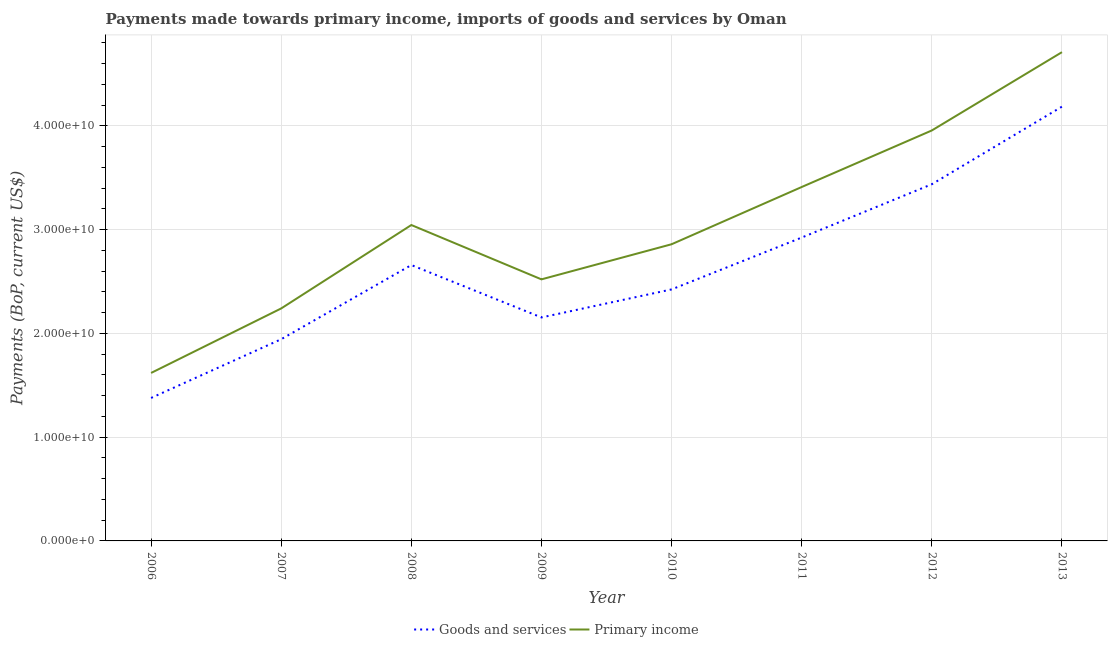What is the payments made towards primary income in 2013?
Make the answer very short. 4.71e+1. Across all years, what is the maximum payments made towards primary income?
Provide a succinct answer. 4.71e+1. Across all years, what is the minimum payments made towards primary income?
Provide a succinct answer. 1.62e+1. In which year was the payments made towards goods and services minimum?
Your answer should be compact. 2006. What is the total payments made towards primary income in the graph?
Make the answer very short. 2.44e+11. What is the difference between the payments made towards primary income in 2006 and that in 2012?
Offer a very short reply. -2.34e+1. What is the difference between the payments made towards goods and services in 2013 and the payments made towards primary income in 2008?
Your response must be concise. 1.14e+1. What is the average payments made towards goods and services per year?
Offer a very short reply. 2.64e+1. In the year 2007, what is the difference between the payments made towards goods and services and payments made towards primary income?
Your answer should be compact. -2.97e+09. What is the ratio of the payments made towards primary income in 2012 to that in 2013?
Keep it short and to the point. 0.84. Is the payments made towards goods and services in 2006 less than that in 2011?
Give a very brief answer. Yes. What is the difference between the highest and the second highest payments made towards primary income?
Provide a short and direct response. 7.54e+09. What is the difference between the highest and the lowest payments made towards goods and services?
Make the answer very short. 2.81e+1. Is the sum of the payments made towards primary income in 2010 and 2013 greater than the maximum payments made towards goods and services across all years?
Provide a succinct answer. Yes. Is the payments made towards primary income strictly greater than the payments made towards goods and services over the years?
Your answer should be compact. Yes. Is the payments made towards primary income strictly less than the payments made towards goods and services over the years?
Make the answer very short. No. What is the difference between two consecutive major ticks on the Y-axis?
Make the answer very short. 1.00e+1. Are the values on the major ticks of Y-axis written in scientific E-notation?
Provide a succinct answer. Yes. Does the graph contain any zero values?
Ensure brevity in your answer.  No. Does the graph contain grids?
Keep it short and to the point. Yes. Where does the legend appear in the graph?
Offer a terse response. Bottom center. What is the title of the graph?
Keep it short and to the point. Payments made towards primary income, imports of goods and services by Oman. What is the label or title of the Y-axis?
Your response must be concise. Payments (BoP, current US$). What is the Payments (BoP, current US$) in Goods and services in 2006?
Your response must be concise. 1.38e+1. What is the Payments (BoP, current US$) in Primary income in 2006?
Offer a very short reply. 1.62e+1. What is the Payments (BoP, current US$) in Goods and services in 2007?
Offer a terse response. 1.94e+1. What is the Payments (BoP, current US$) in Primary income in 2007?
Ensure brevity in your answer.  2.24e+1. What is the Payments (BoP, current US$) in Goods and services in 2008?
Give a very brief answer. 2.66e+1. What is the Payments (BoP, current US$) of Primary income in 2008?
Your answer should be compact. 3.04e+1. What is the Payments (BoP, current US$) in Goods and services in 2009?
Offer a very short reply. 2.15e+1. What is the Payments (BoP, current US$) in Primary income in 2009?
Offer a terse response. 2.52e+1. What is the Payments (BoP, current US$) of Goods and services in 2010?
Your answer should be very brief. 2.42e+1. What is the Payments (BoP, current US$) in Primary income in 2010?
Ensure brevity in your answer.  2.86e+1. What is the Payments (BoP, current US$) in Goods and services in 2011?
Your answer should be very brief. 2.92e+1. What is the Payments (BoP, current US$) of Primary income in 2011?
Ensure brevity in your answer.  3.41e+1. What is the Payments (BoP, current US$) in Goods and services in 2012?
Make the answer very short. 3.44e+1. What is the Payments (BoP, current US$) in Primary income in 2012?
Your answer should be compact. 3.96e+1. What is the Payments (BoP, current US$) of Goods and services in 2013?
Keep it short and to the point. 4.18e+1. What is the Payments (BoP, current US$) in Primary income in 2013?
Your response must be concise. 4.71e+1. Across all years, what is the maximum Payments (BoP, current US$) in Goods and services?
Offer a very short reply. 4.18e+1. Across all years, what is the maximum Payments (BoP, current US$) in Primary income?
Offer a terse response. 4.71e+1. Across all years, what is the minimum Payments (BoP, current US$) of Goods and services?
Give a very brief answer. 1.38e+1. Across all years, what is the minimum Payments (BoP, current US$) of Primary income?
Provide a succinct answer. 1.62e+1. What is the total Payments (BoP, current US$) in Goods and services in the graph?
Make the answer very short. 2.11e+11. What is the total Payments (BoP, current US$) in Primary income in the graph?
Offer a terse response. 2.44e+11. What is the difference between the Payments (BoP, current US$) in Goods and services in 2006 and that in 2007?
Give a very brief answer. -5.66e+09. What is the difference between the Payments (BoP, current US$) of Primary income in 2006 and that in 2007?
Keep it short and to the point. -6.22e+09. What is the difference between the Payments (BoP, current US$) in Goods and services in 2006 and that in 2008?
Provide a short and direct response. -1.28e+1. What is the difference between the Payments (BoP, current US$) of Primary income in 2006 and that in 2008?
Ensure brevity in your answer.  -1.43e+1. What is the difference between the Payments (BoP, current US$) in Goods and services in 2006 and that in 2009?
Your response must be concise. -7.76e+09. What is the difference between the Payments (BoP, current US$) in Primary income in 2006 and that in 2009?
Make the answer very short. -9.02e+09. What is the difference between the Payments (BoP, current US$) in Goods and services in 2006 and that in 2010?
Keep it short and to the point. -1.05e+1. What is the difference between the Payments (BoP, current US$) in Primary income in 2006 and that in 2010?
Keep it short and to the point. -1.24e+1. What is the difference between the Payments (BoP, current US$) in Goods and services in 2006 and that in 2011?
Give a very brief answer. -1.55e+1. What is the difference between the Payments (BoP, current US$) in Primary income in 2006 and that in 2011?
Keep it short and to the point. -1.79e+1. What is the difference between the Payments (BoP, current US$) in Goods and services in 2006 and that in 2012?
Provide a short and direct response. -2.06e+1. What is the difference between the Payments (BoP, current US$) in Primary income in 2006 and that in 2012?
Your response must be concise. -2.34e+1. What is the difference between the Payments (BoP, current US$) of Goods and services in 2006 and that in 2013?
Ensure brevity in your answer.  -2.81e+1. What is the difference between the Payments (BoP, current US$) of Primary income in 2006 and that in 2013?
Your response must be concise. -3.09e+1. What is the difference between the Payments (BoP, current US$) in Goods and services in 2007 and that in 2008?
Give a very brief answer. -7.15e+09. What is the difference between the Payments (BoP, current US$) of Primary income in 2007 and that in 2008?
Provide a short and direct response. -8.04e+09. What is the difference between the Payments (BoP, current US$) of Goods and services in 2007 and that in 2009?
Your answer should be very brief. -2.10e+09. What is the difference between the Payments (BoP, current US$) in Primary income in 2007 and that in 2009?
Provide a succinct answer. -2.80e+09. What is the difference between the Payments (BoP, current US$) of Goods and services in 2007 and that in 2010?
Your response must be concise. -4.80e+09. What is the difference between the Payments (BoP, current US$) in Primary income in 2007 and that in 2010?
Provide a succinct answer. -6.19e+09. What is the difference between the Payments (BoP, current US$) in Goods and services in 2007 and that in 2011?
Offer a very short reply. -9.80e+09. What is the difference between the Payments (BoP, current US$) in Primary income in 2007 and that in 2011?
Make the answer very short. -1.17e+1. What is the difference between the Payments (BoP, current US$) of Goods and services in 2007 and that in 2012?
Provide a succinct answer. -1.49e+1. What is the difference between the Payments (BoP, current US$) in Primary income in 2007 and that in 2012?
Provide a short and direct response. -1.72e+1. What is the difference between the Payments (BoP, current US$) of Goods and services in 2007 and that in 2013?
Your response must be concise. -2.24e+1. What is the difference between the Payments (BoP, current US$) in Primary income in 2007 and that in 2013?
Your response must be concise. -2.47e+1. What is the difference between the Payments (BoP, current US$) in Goods and services in 2008 and that in 2009?
Provide a short and direct response. 5.05e+09. What is the difference between the Payments (BoP, current US$) in Primary income in 2008 and that in 2009?
Your answer should be compact. 5.24e+09. What is the difference between the Payments (BoP, current US$) in Goods and services in 2008 and that in 2010?
Your response must be concise. 2.35e+09. What is the difference between the Payments (BoP, current US$) of Primary income in 2008 and that in 2010?
Provide a short and direct response. 1.85e+09. What is the difference between the Payments (BoP, current US$) of Goods and services in 2008 and that in 2011?
Provide a succinct answer. -2.65e+09. What is the difference between the Payments (BoP, current US$) in Primary income in 2008 and that in 2011?
Your response must be concise. -3.66e+09. What is the difference between the Payments (BoP, current US$) of Goods and services in 2008 and that in 2012?
Offer a terse response. -7.79e+09. What is the difference between the Payments (BoP, current US$) of Primary income in 2008 and that in 2012?
Offer a very short reply. -9.11e+09. What is the difference between the Payments (BoP, current US$) in Goods and services in 2008 and that in 2013?
Offer a terse response. -1.53e+1. What is the difference between the Payments (BoP, current US$) in Primary income in 2008 and that in 2013?
Provide a short and direct response. -1.67e+1. What is the difference between the Payments (BoP, current US$) of Goods and services in 2009 and that in 2010?
Keep it short and to the point. -2.70e+09. What is the difference between the Payments (BoP, current US$) in Primary income in 2009 and that in 2010?
Provide a short and direct response. -3.38e+09. What is the difference between the Payments (BoP, current US$) in Goods and services in 2009 and that in 2011?
Make the answer very short. -7.70e+09. What is the difference between the Payments (BoP, current US$) in Primary income in 2009 and that in 2011?
Provide a short and direct response. -8.90e+09. What is the difference between the Payments (BoP, current US$) of Goods and services in 2009 and that in 2012?
Provide a short and direct response. -1.28e+1. What is the difference between the Payments (BoP, current US$) of Primary income in 2009 and that in 2012?
Make the answer very short. -1.43e+1. What is the difference between the Payments (BoP, current US$) in Goods and services in 2009 and that in 2013?
Offer a terse response. -2.03e+1. What is the difference between the Payments (BoP, current US$) in Primary income in 2009 and that in 2013?
Ensure brevity in your answer.  -2.19e+1. What is the difference between the Payments (BoP, current US$) in Goods and services in 2010 and that in 2011?
Make the answer very short. -5.00e+09. What is the difference between the Payments (BoP, current US$) of Primary income in 2010 and that in 2011?
Your answer should be very brief. -5.52e+09. What is the difference between the Payments (BoP, current US$) of Goods and services in 2010 and that in 2012?
Your answer should be compact. -1.01e+1. What is the difference between the Payments (BoP, current US$) in Primary income in 2010 and that in 2012?
Your answer should be very brief. -1.10e+1. What is the difference between the Payments (BoP, current US$) in Goods and services in 2010 and that in 2013?
Give a very brief answer. -1.76e+1. What is the difference between the Payments (BoP, current US$) in Primary income in 2010 and that in 2013?
Your answer should be compact. -1.85e+1. What is the difference between the Payments (BoP, current US$) in Goods and services in 2011 and that in 2012?
Your response must be concise. -5.14e+09. What is the difference between the Payments (BoP, current US$) of Primary income in 2011 and that in 2012?
Make the answer very short. -5.45e+09. What is the difference between the Payments (BoP, current US$) of Goods and services in 2011 and that in 2013?
Ensure brevity in your answer.  -1.26e+1. What is the difference between the Payments (BoP, current US$) in Primary income in 2011 and that in 2013?
Give a very brief answer. -1.30e+1. What is the difference between the Payments (BoP, current US$) in Goods and services in 2012 and that in 2013?
Keep it short and to the point. -7.48e+09. What is the difference between the Payments (BoP, current US$) in Primary income in 2012 and that in 2013?
Ensure brevity in your answer.  -7.54e+09. What is the difference between the Payments (BoP, current US$) of Goods and services in 2006 and the Payments (BoP, current US$) of Primary income in 2007?
Your answer should be very brief. -8.63e+09. What is the difference between the Payments (BoP, current US$) in Goods and services in 2006 and the Payments (BoP, current US$) in Primary income in 2008?
Ensure brevity in your answer.  -1.67e+1. What is the difference between the Payments (BoP, current US$) of Goods and services in 2006 and the Payments (BoP, current US$) of Primary income in 2009?
Provide a succinct answer. -1.14e+1. What is the difference between the Payments (BoP, current US$) of Goods and services in 2006 and the Payments (BoP, current US$) of Primary income in 2010?
Your answer should be very brief. -1.48e+1. What is the difference between the Payments (BoP, current US$) in Goods and services in 2006 and the Payments (BoP, current US$) in Primary income in 2011?
Keep it short and to the point. -2.03e+1. What is the difference between the Payments (BoP, current US$) of Goods and services in 2006 and the Payments (BoP, current US$) of Primary income in 2012?
Provide a succinct answer. -2.58e+1. What is the difference between the Payments (BoP, current US$) in Goods and services in 2006 and the Payments (BoP, current US$) in Primary income in 2013?
Make the answer very short. -3.33e+1. What is the difference between the Payments (BoP, current US$) of Goods and services in 2007 and the Payments (BoP, current US$) of Primary income in 2008?
Give a very brief answer. -1.10e+1. What is the difference between the Payments (BoP, current US$) in Goods and services in 2007 and the Payments (BoP, current US$) in Primary income in 2009?
Keep it short and to the point. -5.77e+09. What is the difference between the Payments (BoP, current US$) in Goods and services in 2007 and the Payments (BoP, current US$) in Primary income in 2010?
Offer a terse response. -9.15e+09. What is the difference between the Payments (BoP, current US$) in Goods and services in 2007 and the Payments (BoP, current US$) in Primary income in 2011?
Your answer should be compact. -1.47e+1. What is the difference between the Payments (BoP, current US$) of Goods and services in 2007 and the Payments (BoP, current US$) of Primary income in 2012?
Give a very brief answer. -2.01e+1. What is the difference between the Payments (BoP, current US$) of Goods and services in 2007 and the Payments (BoP, current US$) of Primary income in 2013?
Give a very brief answer. -2.77e+1. What is the difference between the Payments (BoP, current US$) in Goods and services in 2008 and the Payments (BoP, current US$) in Primary income in 2009?
Your answer should be very brief. 1.38e+09. What is the difference between the Payments (BoP, current US$) in Goods and services in 2008 and the Payments (BoP, current US$) in Primary income in 2010?
Provide a short and direct response. -2.00e+09. What is the difference between the Payments (BoP, current US$) of Goods and services in 2008 and the Payments (BoP, current US$) of Primary income in 2011?
Make the answer very short. -7.52e+09. What is the difference between the Payments (BoP, current US$) in Goods and services in 2008 and the Payments (BoP, current US$) in Primary income in 2012?
Keep it short and to the point. -1.30e+1. What is the difference between the Payments (BoP, current US$) of Goods and services in 2008 and the Payments (BoP, current US$) of Primary income in 2013?
Make the answer very short. -2.05e+1. What is the difference between the Payments (BoP, current US$) of Goods and services in 2009 and the Payments (BoP, current US$) of Primary income in 2010?
Give a very brief answer. -7.05e+09. What is the difference between the Payments (BoP, current US$) in Goods and services in 2009 and the Payments (BoP, current US$) in Primary income in 2011?
Offer a very short reply. -1.26e+1. What is the difference between the Payments (BoP, current US$) of Goods and services in 2009 and the Payments (BoP, current US$) of Primary income in 2012?
Provide a short and direct response. -1.80e+1. What is the difference between the Payments (BoP, current US$) of Goods and services in 2009 and the Payments (BoP, current US$) of Primary income in 2013?
Offer a terse response. -2.56e+1. What is the difference between the Payments (BoP, current US$) of Goods and services in 2010 and the Payments (BoP, current US$) of Primary income in 2011?
Provide a short and direct response. -9.87e+09. What is the difference between the Payments (BoP, current US$) of Goods and services in 2010 and the Payments (BoP, current US$) of Primary income in 2012?
Provide a short and direct response. -1.53e+1. What is the difference between the Payments (BoP, current US$) of Goods and services in 2010 and the Payments (BoP, current US$) of Primary income in 2013?
Your answer should be very brief. -2.29e+1. What is the difference between the Payments (BoP, current US$) of Goods and services in 2011 and the Payments (BoP, current US$) of Primary income in 2012?
Ensure brevity in your answer.  -1.03e+1. What is the difference between the Payments (BoP, current US$) in Goods and services in 2011 and the Payments (BoP, current US$) in Primary income in 2013?
Your answer should be compact. -1.79e+1. What is the difference between the Payments (BoP, current US$) in Goods and services in 2012 and the Payments (BoP, current US$) in Primary income in 2013?
Provide a short and direct response. -1.27e+1. What is the average Payments (BoP, current US$) of Goods and services per year?
Give a very brief answer. 2.64e+1. What is the average Payments (BoP, current US$) of Primary income per year?
Your answer should be very brief. 3.04e+1. In the year 2006, what is the difference between the Payments (BoP, current US$) in Goods and services and Payments (BoP, current US$) in Primary income?
Provide a succinct answer. -2.41e+09. In the year 2007, what is the difference between the Payments (BoP, current US$) of Goods and services and Payments (BoP, current US$) of Primary income?
Give a very brief answer. -2.97e+09. In the year 2008, what is the difference between the Payments (BoP, current US$) of Goods and services and Payments (BoP, current US$) of Primary income?
Ensure brevity in your answer.  -3.86e+09. In the year 2009, what is the difference between the Payments (BoP, current US$) of Goods and services and Payments (BoP, current US$) of Primary income?
Your response must be concise. -3.67e+09. In the year 2010, what is the difference between the Payments (BoP, current US$) in Goods and services and Payments (BoP, current US$) in Primary income?
Your answer should be very brief. -4.35e+09. In the year 2011, what is the difference between the Payments (BoP, current US$) of Goods and services and Payments (BoP, current US$) of Primary income?
Keep it short and to the point. -4.87e+09. In the year 2012, what is the difference between the Payments (BoP, current US$) of Goods and services and Payments (BoP, current US$) of Primary income?
Offer a very short reply. -5.18e+09. In the year 2013, what is the difference between the Payments (BoP, current US$) in Goods and services and Payments (BoP, current US$) in Primary income?
Make the answer very short. -5.25e+09. What is the ratio of the Payments (BoP, current US$) of Goods and services in 2006 to that in 2007?
Offer a very short reply. 0.71. What is the ratio of the Payments (BoP, current US$) of Primary income in 2006 to that in 2007?
Give a very brief answer. 0.72. What is the ratio of the Payments (BoP, current US$) of Goods and services in 2006 to that in 2008?
Make the answer very short. 0.52. What is the ratio of the Payments (BoP, current US$) of Primary income in 2006 to that in 2008?
Make the answer very short. 0.53. What is the ratio of the Payments (BoP, current US$) in Goods and services in 2006 to that in 2009?
Your answer should be compact. 0.64. What is the ratio of the Payments (BoP, current US$) of Primary income in 2006 to that in 2009?
Provide a short and direct response. 0.64. What is the ratio of the Payments (BoP, current US$) of Goods and services in 2006 to that in 2010?
Your answer should be compact. 0.57. What is the ratio of the Payments (BoP, current US$) of Primary income in 2006 to that in 2010?
Your answer should be very brief. 0.57. What is the ratio of the Payments (BoP, current US$) of Goods and services in 2006 to that in 2011?
Give a very brief answer. 0.47. What is the ratio of the Payments (BoP, current US$) of Primary income in 2006 to that in 2011?
Your answer should be compact. 0.47. What is the ratio of the Payments (BoP, current US$) in Goods and services in 2006 to that in 2012?
Ensure brevity in your answer.  0.4. What is the ratio of the Payments (BoP, current US$) of Primary income in 2006 to that in 2012?
Provide a short and direct response. 0.41. What is the ratio of the Payments (BoP, current US$) of Goods and services in 2006 to that in 2013?
Offer a terse response. 0.33. What is the ratio of the Payments (BoP, current US$) in Primary income in 2006 to that in 2013?
Your response must be concise. 0.34. What is the ratio of the Payments (BoP, current US$) of Goods and services in 2007 to that in 2008?
Offer a terse response. 0.73. What is the ratio of the Payments (BoP, current US$) of Primary income in 2007 to that in 2008?
Offer a terse response. 0.74. What is the ratio of the Payments (BoP, current US$) of Goods and services in 2007 to that in 2009?
Make the answer very short. 0.9. What is the ratio of the Payments (BoP, current US$) of Primary income in 2007 to that in 2009?
Offer a very short reply. 0.89. What is the ratio of the Payments (BoP, current US$) in Goods and services in 2007 to that in 2010?
Ensure brevity in your answer.  0.8. What is the ratio of the Payments (BoP, current US$) of Primary income in 2007 to that in 2010?
Your answer should be very brief. 0.78. What is the ratio of the Payments (BoP, current US$) in Goods and services in 2007 to that in 2011?
Provide a short and direct response. 0.66. What is the ratio of the Payments (BoP, current US$) in Primary income in 2007 to that in 2011?
Provide a short and direct response. 0.66. What is the ratio of the Payments (BoP, current US$) in Goods and services in 2007 to that in 2012?
Offer a very short reply. 0.57. What is the ratio of the Payments (BoP, current US$) in Primary income in 2007 to that in 2012?
Provide a succinct answer. 0.57. What is the ratio of the Payments (BoP, current US$) of Goods and services in 2007 to that in 2013?
Your answer should be very brief. 0.46. What is the ratio of the Payments (BoP, current US$) of Primary income in 2007 to that in 2013?
Your answer should be compact. 0.48. What is the ratio of the Payments (BoP, current US$) in Goods and services in 2008 to that in 2009?
Give a very brief answer. 1.23. What is the ratio of the Payments (BoP, current US$) in Primary income in 2008 to that in 2009?
Your answer should be compact. 1.21. What is the ratio of the Payments (BoP, current US$) in Goods and services in 2008 to that in 2010?
Provide a succinct answer. 1.1. What is the ratio of the Payments (BoP, current US$) in Primary income in 2008 to that in 2010?
Make the answer very short. 1.06. What is the ratio of the Payments (BoP, current US$) of Goods and services in 2008 to that in 2011?
Offer a terse response. 0.91. What is the ratio of the Payments (BoP, current US$) of Primary income in 2008 to that in 2011?
Give a very brief answer. 0.89. What is the ratio of the Payments (BoP, current US$) in Goods and services in 2008 to that in 2012?
Offer a very short reply. 0.77. What is the ratio of the Payments (BoP, current US$) of Primary income in 2008 to that in 2012?
Your response must be concise. 0.77. What is the ratio of the Payments (BoP, current US$) of Goods and services in 2008 to that in 2013?
Your answer should be very brief. 0.64. What is the ratio of the Payments (BoP, current US$) of Primary income in 2008 to that in 2013?
Make the answer very short. 0.65. What is the ratio of the Payments (BoP, current US$) of Goods and services in 2009 to that in 2010?
Provide a short and direct response. 0.89. What is the ratio of the Payments (BoP, current US$) in Primary income in 2009 to that in 2010?
Keep it short and to the point. 0.88. What is the ratio of the Payments (BoP, current US$) in Goods and services in 2009 to that in 2011?
Ensure brevity in your answer.  0.74. What is the ratio of the Payments (BoP, current US$) of Primary income in 2009 to that in 2011?
Provide a succinct answer. 0.74. What is the ratio of the Payments (BoP, current US$) of Goods and services in 2009 to that in 2012?
Provide a short and direct response. 0.63. What is the ratio of the Payments (BoP, current US$) in Primary income in 2009 to that in 2012?
Make the answer very short. 0.64. What is the ratio of the Payments (BoP, current US$) of Goods and services in 2009 to that in 2013?
Ensure brevity in your answer.  0.51. What is the ratio of the Payments (BoP, current US$) of Primary income in 2009 to that in 2013?
Your response must be concise. 0.54. What is the ratio of the Payments (BoP, current US$) of Goods and services in 2010 to that in 2011?
Offer a terse response. 0.83. What is the ratio of the Payments (BoP, current US$) of Primary income in 2010 to that in 2011?
Make the answer very short. 0.84. What is the ratio of the Payments (BoP, current US$) of Goods and services in 2010 to that in 2012?
Provide a short and direct response. 0.71. What is the ratio of the Payments (BoP, current US$) in Primary income in 2010 to that in 2012?
Keep it short and to the point. 0.72. What is the ratio of the Payments (BoP, current US$) in Goods and services in 2010 to that in 2013?
Your response must be concise. 0.58. What is the ratio of the Payments (BoP, current US$) of Primary income in 2010 to that in 2013?
Give a very brief answer. 0.61. What is the ratio of the Payments (BoP, current US$) of Goods and services in 2011 to that in 2012?
Your response must be concise. 0.85. What is the ratio of the Payments (BoP, current US$) in Primary income in 2011 to that in 2012?
Ensure brevity in your answer.  0.86. What is the ratio of the Payments (BoP, current US$) in Goods and services in 2011 to that in 2013?
Your answer should be compact. 0.7. What is the ratio of the Payments (BoP, current US$) in Primary income in 2011 to that in 2013?
Offer a very short reply. 0.72. What is the ratio of the Payments (BoP, current US$) in Goods and services in 2012 to that in 2013?
Ensure brevity in your answer.  0.82. What is the ratio of the Payments (BoP, current US$) of Primary income in 2012 to that in 2013?
Offer a terse response. 0.84. What is the difference between the highest and the second highest Payments (BoP, current US$) in Goods and services?
Your answer should be compact. 7.48e+09. What is the difference between the highest and the second highest Payments (BoP, current US$) in Primary income?
Provide a succinct answer. 7.54e+09. What is the difference between the highest and the lowest Payments (BoP, current US$) in Goods and services?
Offer a terse response. 2.81e+1. What is the difference between the highest and the lowest Payments (BoP, current US$) of Primary income?
Keep it short and to the point. 3.09e+1. 